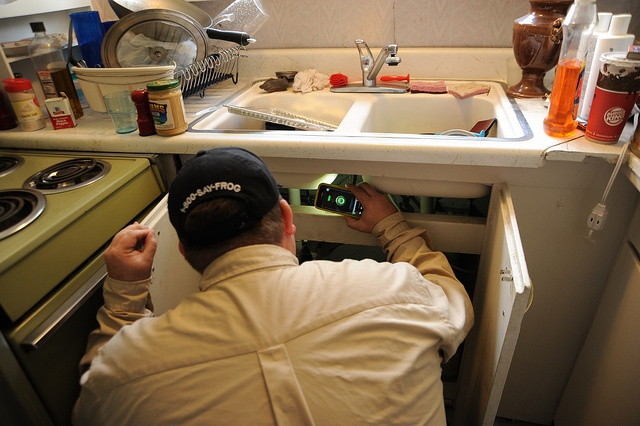Describe the objects in this image and their specific colors. I can see people in darkgray, tan, olive, and black tones, oven in darkgray, black, and olive tones, sink in darkgray, tan, and white tones, sink in darkgray, tan, and white tones, and bottle in darkgray, red, lightgray, and tan tones in this image. 